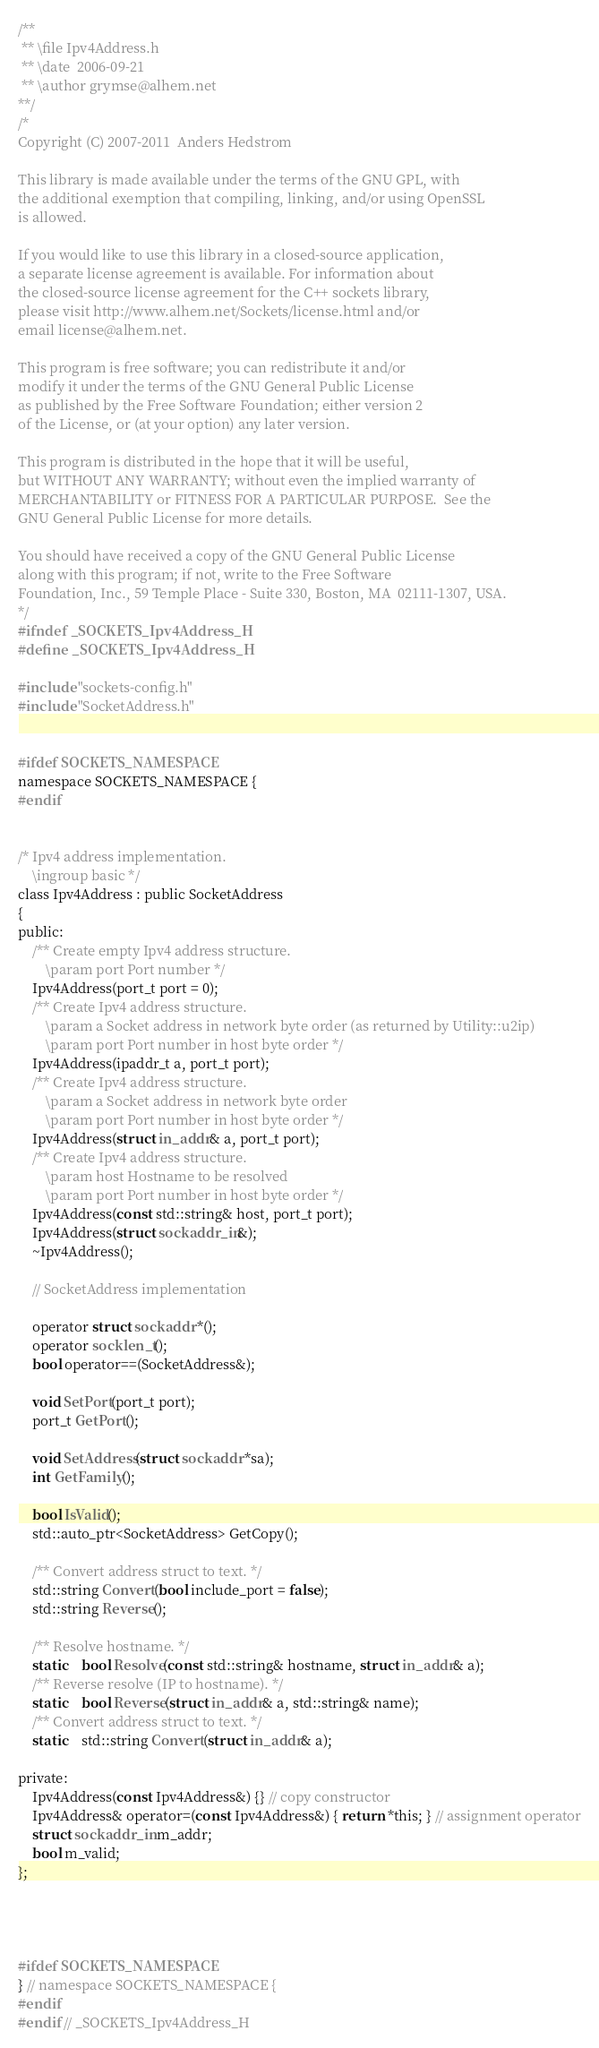Convert code to text. <code><loc_0><loc_0><loc_500><loc_500><_C_>/**
 **	\file Ipv4Address.h
 **	\date  2006-09-21
 **	\author grymse@alhem.net
**/
/*
Copyright (C) 2007-2011  Anders Hedstrom

This library is made available under the terms of the GNU GPL, with
the additional exemption that compiling, linking, and/or using OpenSSL
is allowed.

If you would like to use this library in a closed-source application,
a separate license agreement is available. For information about
the closed-source license agreement for the C++ sockets library,
please visit http://www.alhem.net/Sockets/license.html and/or
email license@alhem.net.

This program is free software; you can redistribute it and/or
modify it under the terms of the GNU General Public License
as published by the Free Software Foundation; either version 2
of the License, or (at your option) any later version.

This program is distributed in the hope that it will be useful,
but WITHOUT ANY WARRANTY; without even the implied warranty of
MERCHANTABILITY or FITNESS FOR A PARTICULAR PURPOSE.  See the
GNU General Public License for more details.

You should have received a copy of the GNU General Public License
along with this program; if not, write to the Free Software
Foundation, Inc., 59 Temple Place - Suite 330, Boston, MA  02111-1307, USA.
*/
#ifndef _SOCKETS_Ipv4Address_H
#define _SOCKETS_Ipv4Address_H

#include "sockets-config.h"
#include "SocketAddress.h"


#ifdef SOCKETS_NAMESPACE
namespace SOCKETS_NAMESPACE {
#endif


/* Ipv4 address implementation.
    \ingroup basic */
class Ipv4Address : public SocketAddress
{
public:
    /** Create empty Ipv4 address structure.
        \param port Port number */
    Ipv4Address(port_t port = 0);
    /** Create Ipv4 address structure.
        \param a Socket address in network byte order (as returned by Utility::u2ip)
        \param port Port number in host byte order */
    Ipv4Address(ipaddr_t a, port_t port);
    /** Create Ipv4 address structure.
        \param a Socket address in network byte order
        \param port Port number in host byte order */
    Ipv4Address(struct in_addr& a, port_t port);
    /** Create Ipv4 address structure.
        \param host Hostname to be resolved
        \param port Port number in host byte order */
    Ipv4Address(const std::string& host, port_t port);
    Ipv4Address(struct sockaddr_in&);
    ~Ipv4Address();

    // SocketAddress implementation

    operator struct sockaddr *();
    operator socklen_t();
    bool operator==(SocketAddress&);

    void SetPort(port_t port);
    port_t GetPort();

    void SetAddress(struct sockaddr *sa);
    int GetFamily();

    bool IsValid();
    std::auto_ptr<SocketAddress> GetCopy();

    /** Convert address struct to text. */
    std::string Convert(bool include_port = false);
    std::string Reverse();

    /** Resolve hostname. */
    static	bool Resolve(const std::string& hostname, struct in_addr& a);
    /** Reverse resolve (IP to hostname). */
    static	bool Reverse(struct in_addr& a, std::string& name);
    /** Convert address struct to text. */
    static	std::string Convert(struct in_addr& a);

private:
    Ipv4Address(const Ipv4Address&) {} // copy constructor
    Ipv4Address& operator=(const Ipv4Address&) { return *this; } // assignment operator
    struct sockaddr_in m_addr;
    bool m_valid;
};




#ifdef SOCKETS_NAMESPACE
} // namespace SOCKETS_NAMESPACE {
#endif
#endif // _SOCKETS_Ipv4Address_H

</code> 